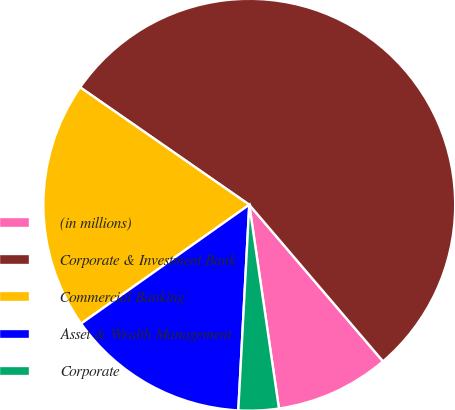Convert chart to OTSL. <chart><loc_0><loc_0><loc_500><loc_500><pie_chart><fcel>(in millions)<fcel>Corporate & Investment Bank<fcel>Commercial Banking<fcel>Asset & Wealth Management<fcel>Corporate<nl><fcel>8.95%<fcel>54.09%<fcel>19.45%<fcel>14.36%<fcel>3.15%<nl></chart> 